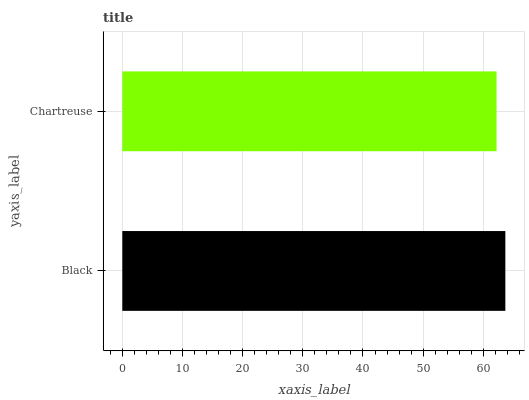Is Chartreuse the minimum?
Answer yes or no. Yes. Is Black the maximum?
Answer yes or no. Yes. Is Chartreuse the maximum?
Answer yes or no. No. Is Black greater than Chartreuse?
Answer yes or no. Yes. Is Chartreuse less than Black?
Answer yes or no. Yes. Is Chartreuse greater than Black?
Answer yes or no. No. Is Black less than Chartreuse?
Answer yes or no. No. Is Black the high median?
Answer yes or no. Yes. Is Chartreuse the low median?
Answer yes or no. Yes. Is Chartreuse the high median?
Answer yes or no. No. Is Black the low median?
Answer yes or no. No. 